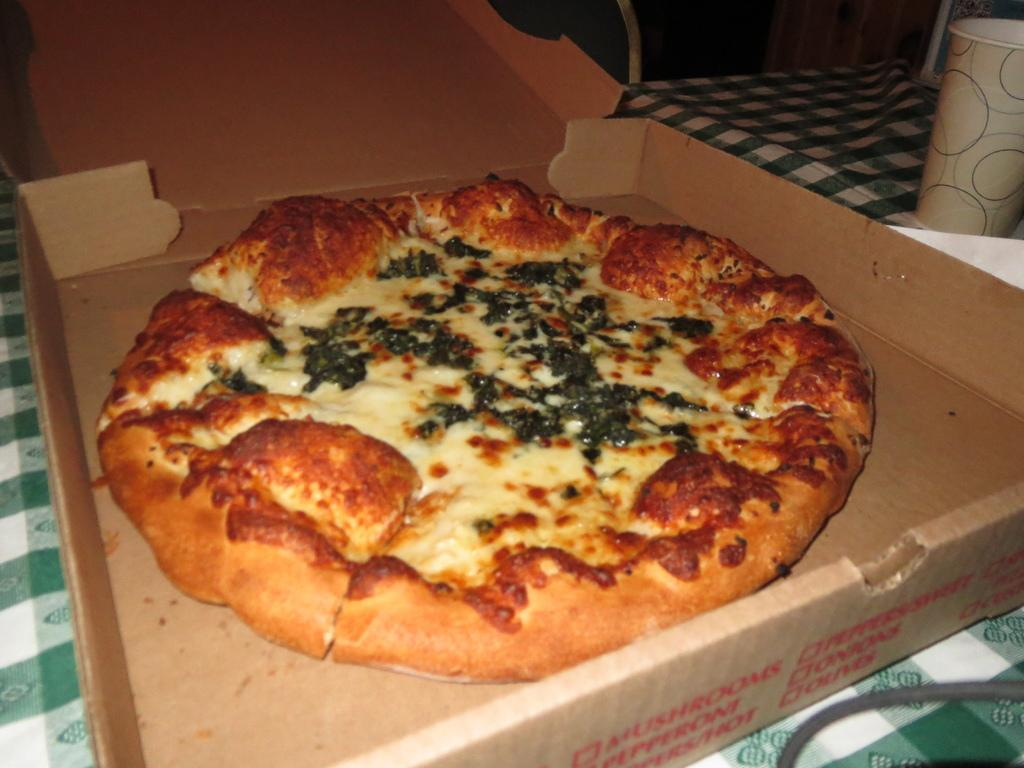What is the main piece of furniture in the image? There is a table in the image. What object is placed on the table? There is a box on the table. What is inside the box? There is a pizza in the box. What type of car is parked next to the table in the image? There is no car present in the image; it only features a table, a box, and a pizza. 